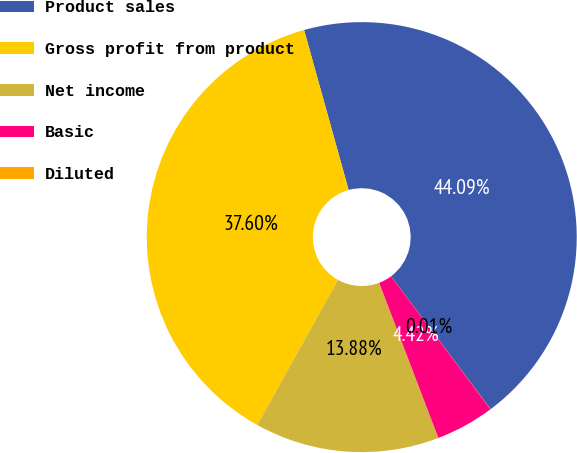Convert chart to OTSL. <chart><loc_0><loc_0><loc_500><loc_500><pie_chart><fcel>Product sales<fcel>Gross profit from product<fcel>Net income<fcel>Basic<fcel>Diluted<nl><fcel>44.09%<fcel>37.6%<fcel>13.88%<fcel>4.42%<fcel>0.01%<nl></chart> 